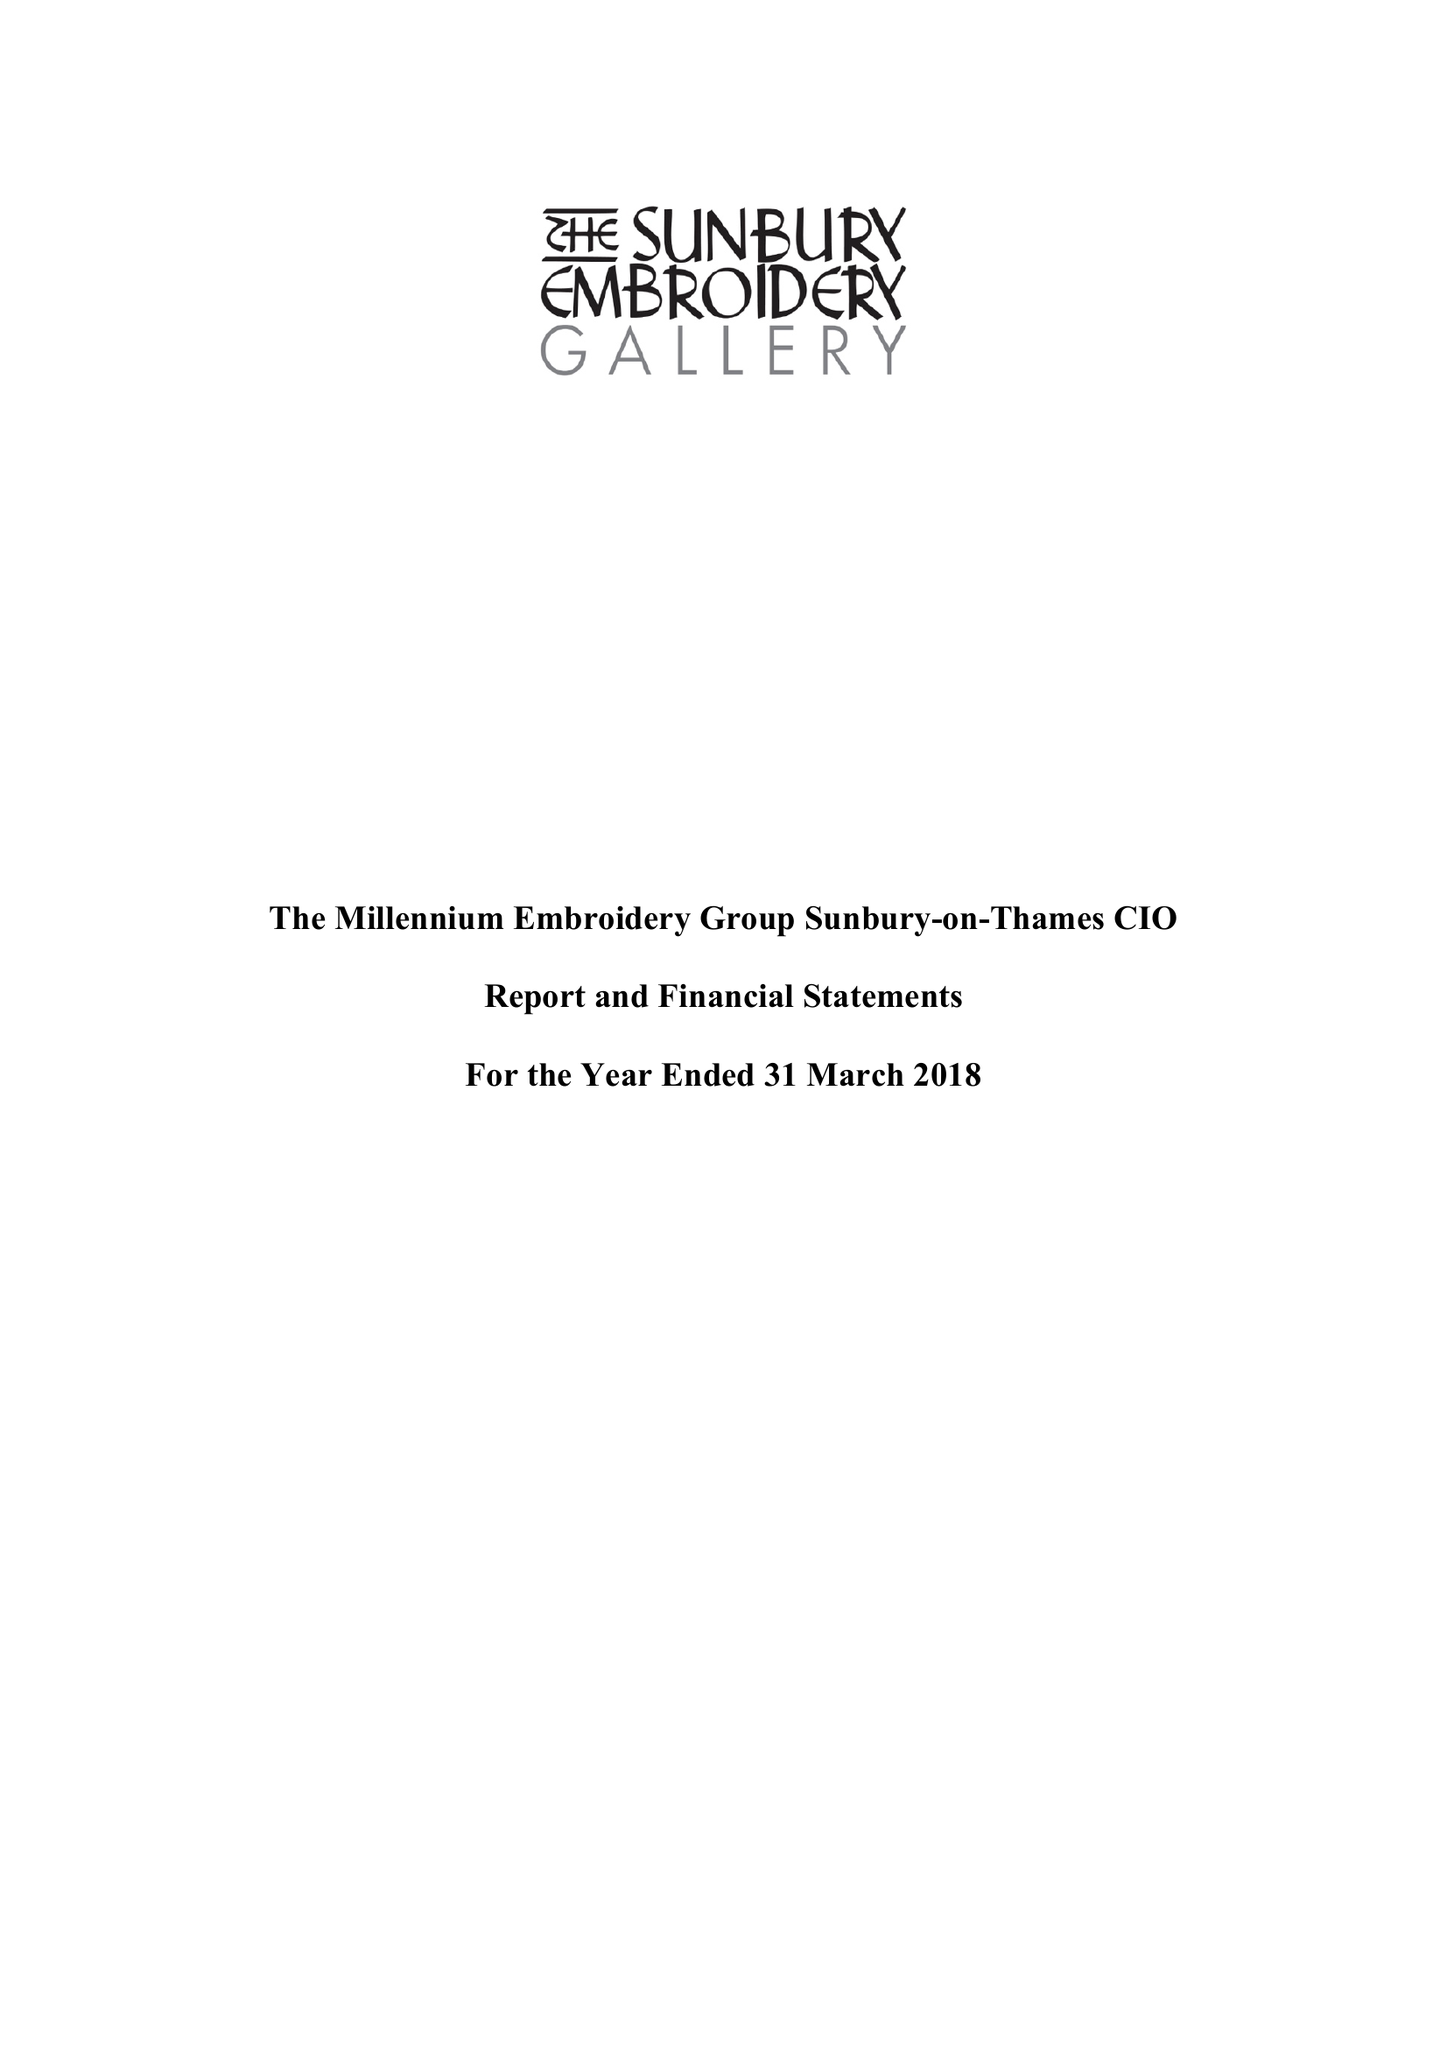What is the value for the address__street_line?
Answer the question using a single word or phrase. THAMES STREET 